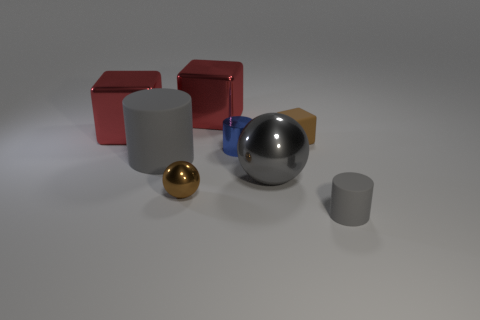What is the color of the rubber cylinder that is the same size as the matte cube?
Provide a succinct answer. Gray. How many gray rubber things are the same shape as the blue object?
Your answer should be very brief. 2. There is a brown cube; is it the same size as the brown thing that is in front of the large matte object?
Keep it short and to the point. Yes. There is a gray shiny thing to the right of the rubber cylinder that is to the left of the blue object; what is its shape?
Provide a short and direct response. Sphere. Is the number of objects left of the tiny brown metallic ball less than the number of things?
Keep it short and to the point. Yes. What shape is the metal thing that is the same color as the large matte cylinder?
Your answer should be compact. Sphere. What number of brown objects are the same size as the blue object?
Your answer should be compact. 2. What shape is the gray rubber thing that is in front of the big gray matte thing?
Provide a succinct answer. Cylinder. Are there fewer small metal things than rubber things?
Keep it short and to the point. Yes. Are there any other things of the same color as the tiny metallic cylinder?
Your answer should be very brief. No. 